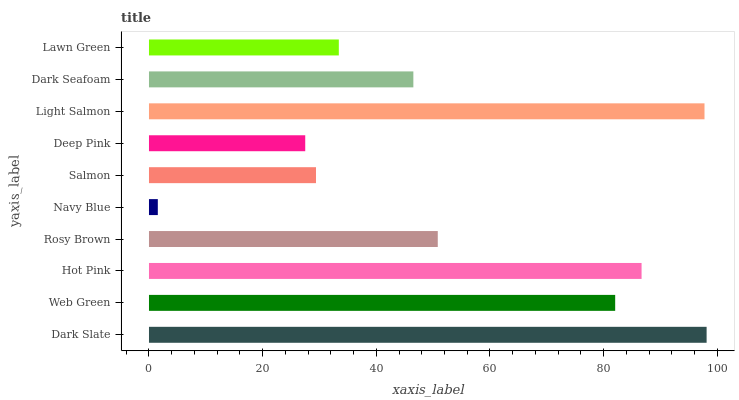Is Navy Blue the minimum?
Answer yes or no. Yes. Is Dark Slate the maximum?
Answer yes or no. Yes. Is Web Green the minimum?
Answer yes or no. No. Is Web Green the maximum?
Answer yes or no. No. Is Dark Slate greater than Web Green?
Answer yes or no. Yes. Is Web Green less than Dark Slate?
Answer yes or no. Yes. Is Web Green greater than Dark Slate?
Answer yes or no. No. Is Dark Slate less than Web Green?
Answer yes or no. No. Is Rosy Brown the high median?
Answer yes or no. Yes. Is Dark Seafoam the low median?
Answer yes or no. Yes. Is Dark Slate the high median?
Answer yes or no. No. Is Salmon the low median?
Answer yes or no. No. 